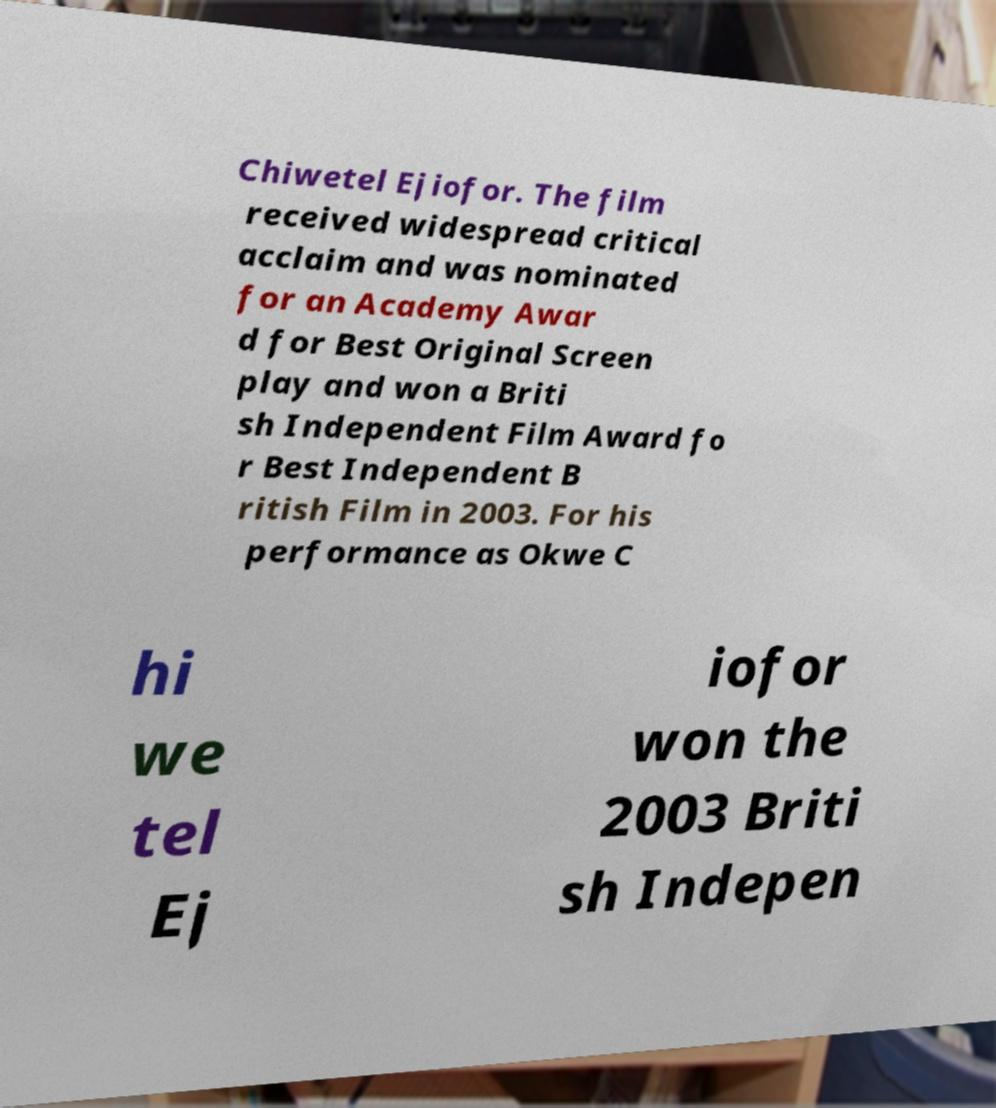Could you extract and type out the text from this image? Chiwetel Ejiofor. The film received widespread critical acclaim and was nominated for an Academy Awar d for Best Original Screen play and won a Briti sh Independent Film Award fo r Best Independent B ritish Film in 2003. For his performance as Okwe C hi we tel Ej iofor won the 2003 Briti sh Indepen 